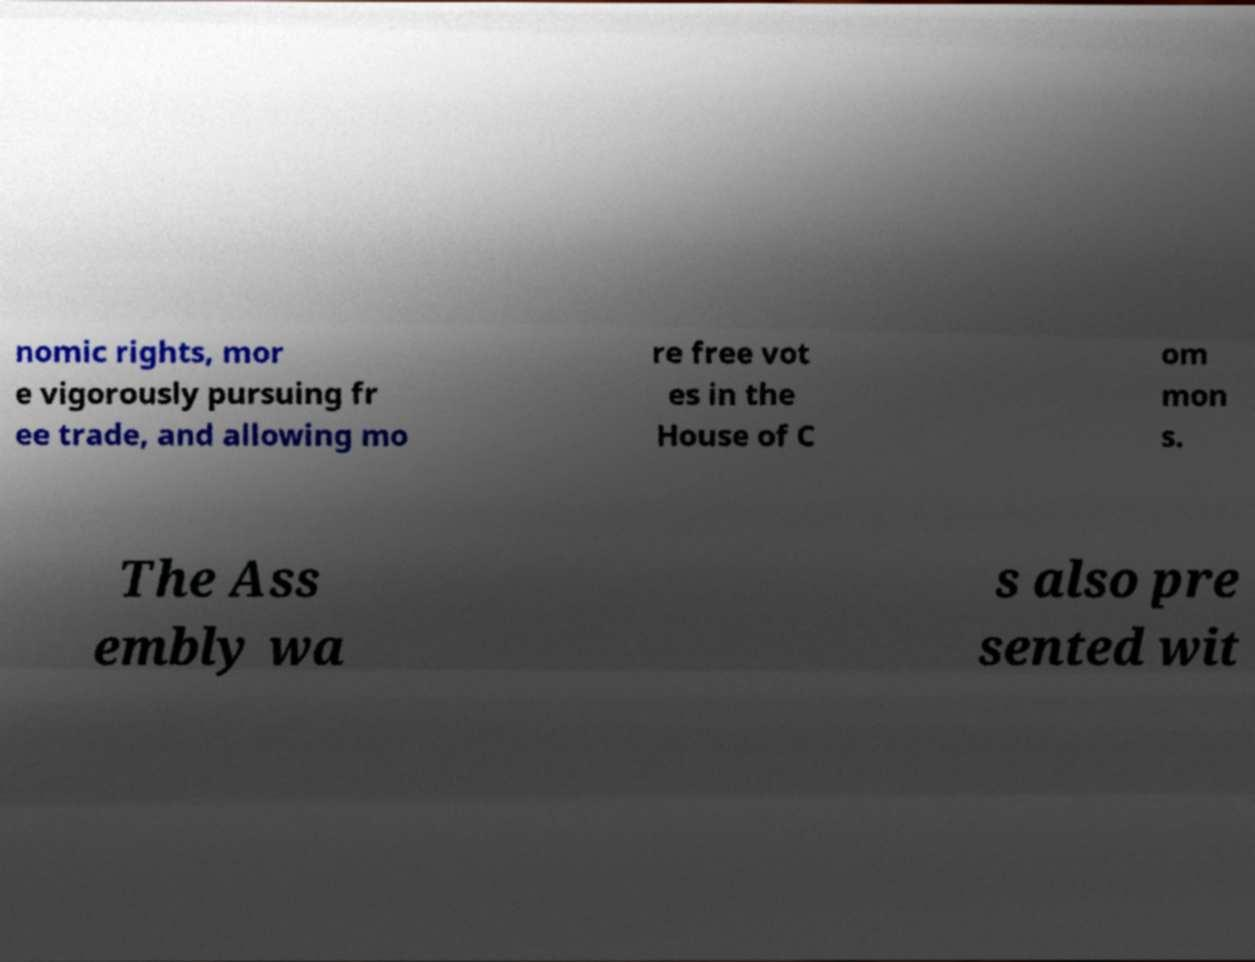Please identify and transcribe the text found in this image. nomic rights, mor e vigorously pursuing fr ee trade, and allowing mo re free vot es in the House of C om mon s. The Ass embly wa s also pre sented wit 